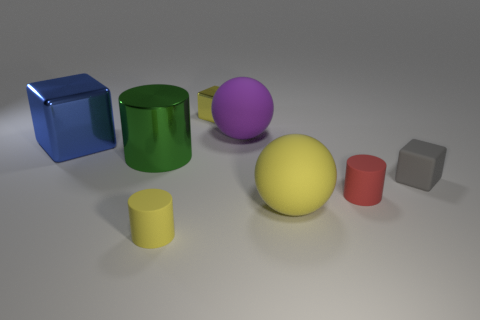Add 1 small cyan rubber cylinders. How many objects exist? 9 Subtract all blocks. How many objects are left? 5 Subtract all red cylinders. Subtract all yellow metal things. How many objects are left? 6 Add 4 big matte things. How many big matte things are left? 6 Add 2 tiny things. How many tiny things exist? 6 Subtract 0 gray spheres. How many objects are left? 8 